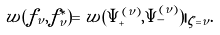Convert formula to latex. <formula><loc_0><loc_0><loc_500><loc_500>w ( f _ { \nu } , f _ { \nu } ^ { \ast } ) = w ( \Psi _ { + } ^ { ( \nu ) } , \Psi _ { - } ^ { ( \nu ) } ) | _ { \zeta = \nu } .</formula> 